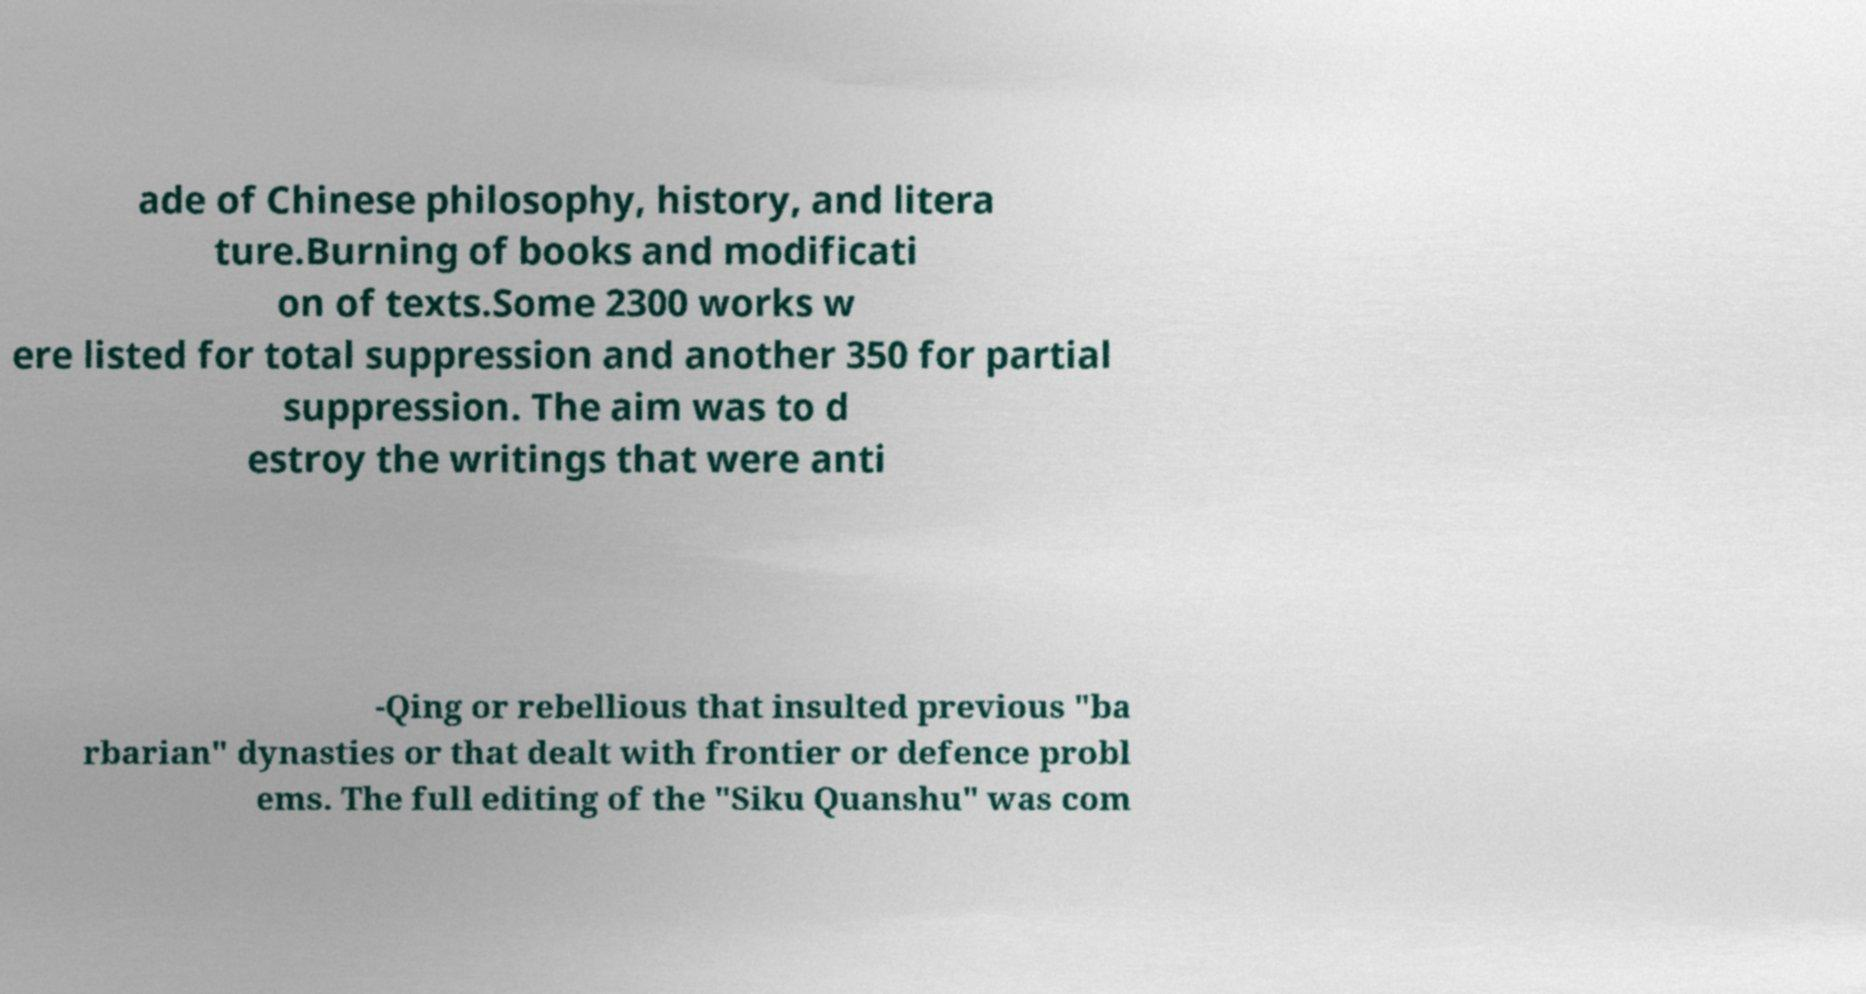Can you read and provide the text displayed in the image?This photo seems to have some interesting text. Can you extract and type it out for me? ade of Chinese philosophy, history, and litera ture.Burning of books and modificati on of texts.Some 2300 works w ere listed for total suppression and another 350 for partial suppression. The aim was to d estroy the writings that were anti -Qing or rebellious that insulted previous "ba rbarian" dynasties or that dealt with frontier or defence probl ems. The full editing of the "Siku Quanshu" was com 